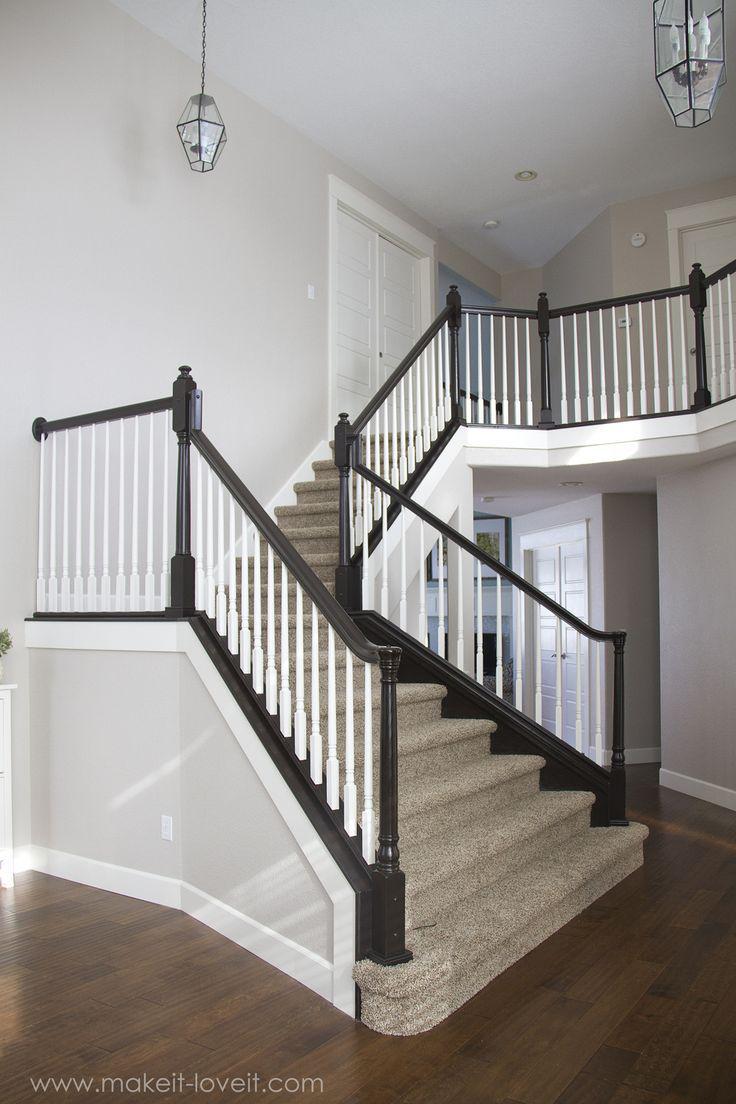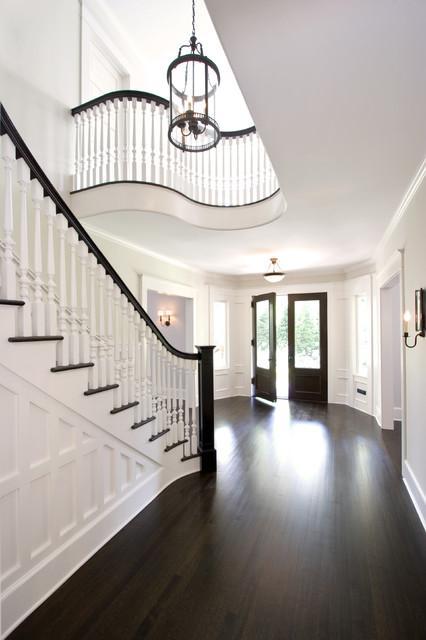The first image is the image on the left, the second image is the image on the right. Analyze the images presented: Is the assertion "In at least on image there a two level empty staircase with a black handle and with rodes to protect someone from falling off." valid? Answer yes or no. Yes. 